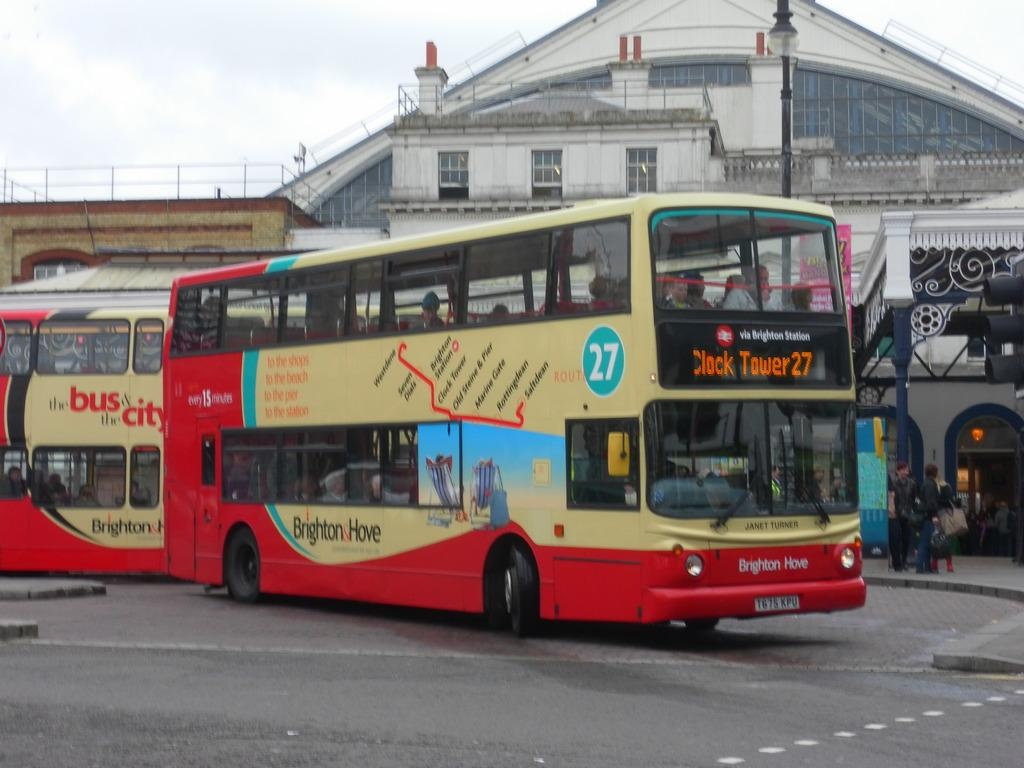<image>
Share a concise interpretation of the image provided. A double decker bus with Clock Tower27 on its front is from Brighten Station. 